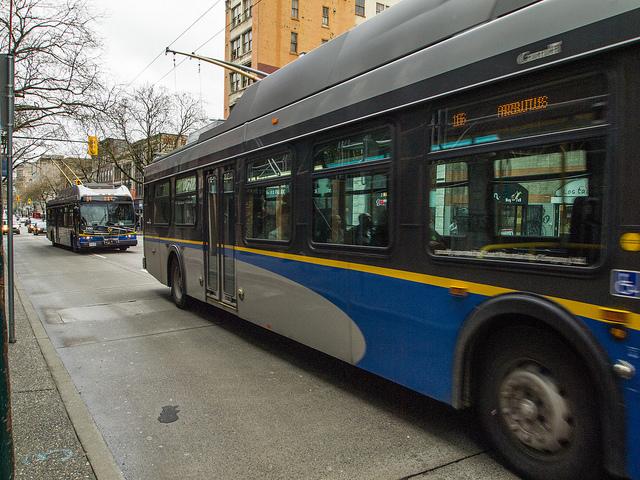Is this a bus?
Quick response, please. Yes. Is the closest bus in motion?
Concise answer only. Yes. Are the buses in a city:?
Quick response, please. Yes. 